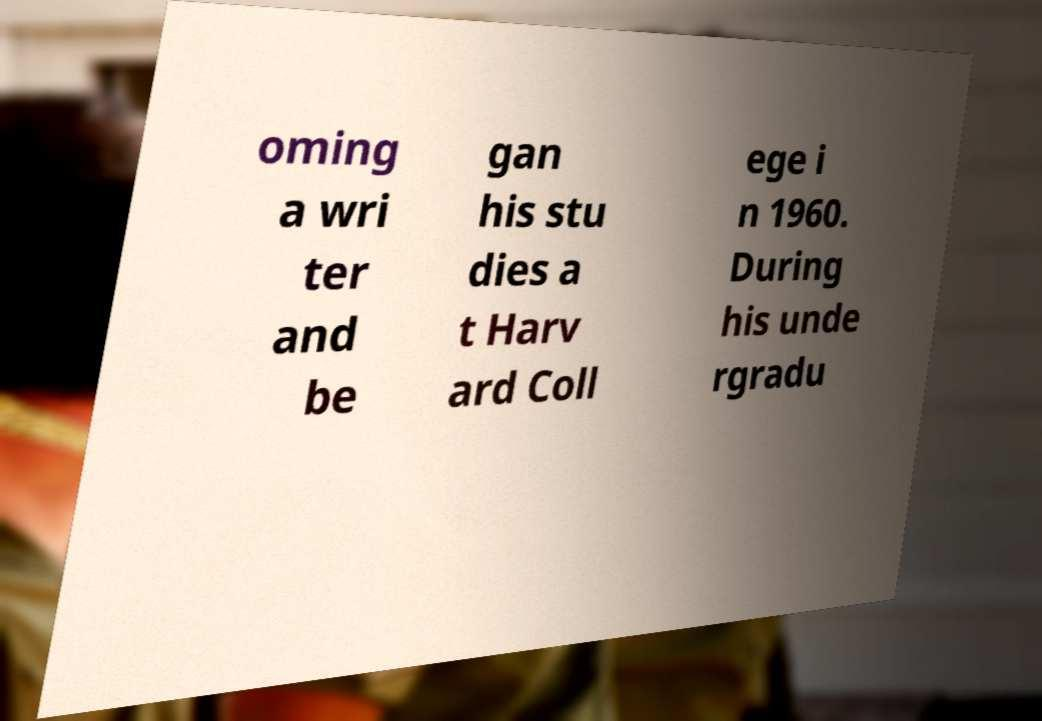Could you assist in decoding the text presented in this image and type it out clearly? oming a wri ter and be gan his stu dies a t Harv ard Coll ege i n 1960. During his unde rgradu 